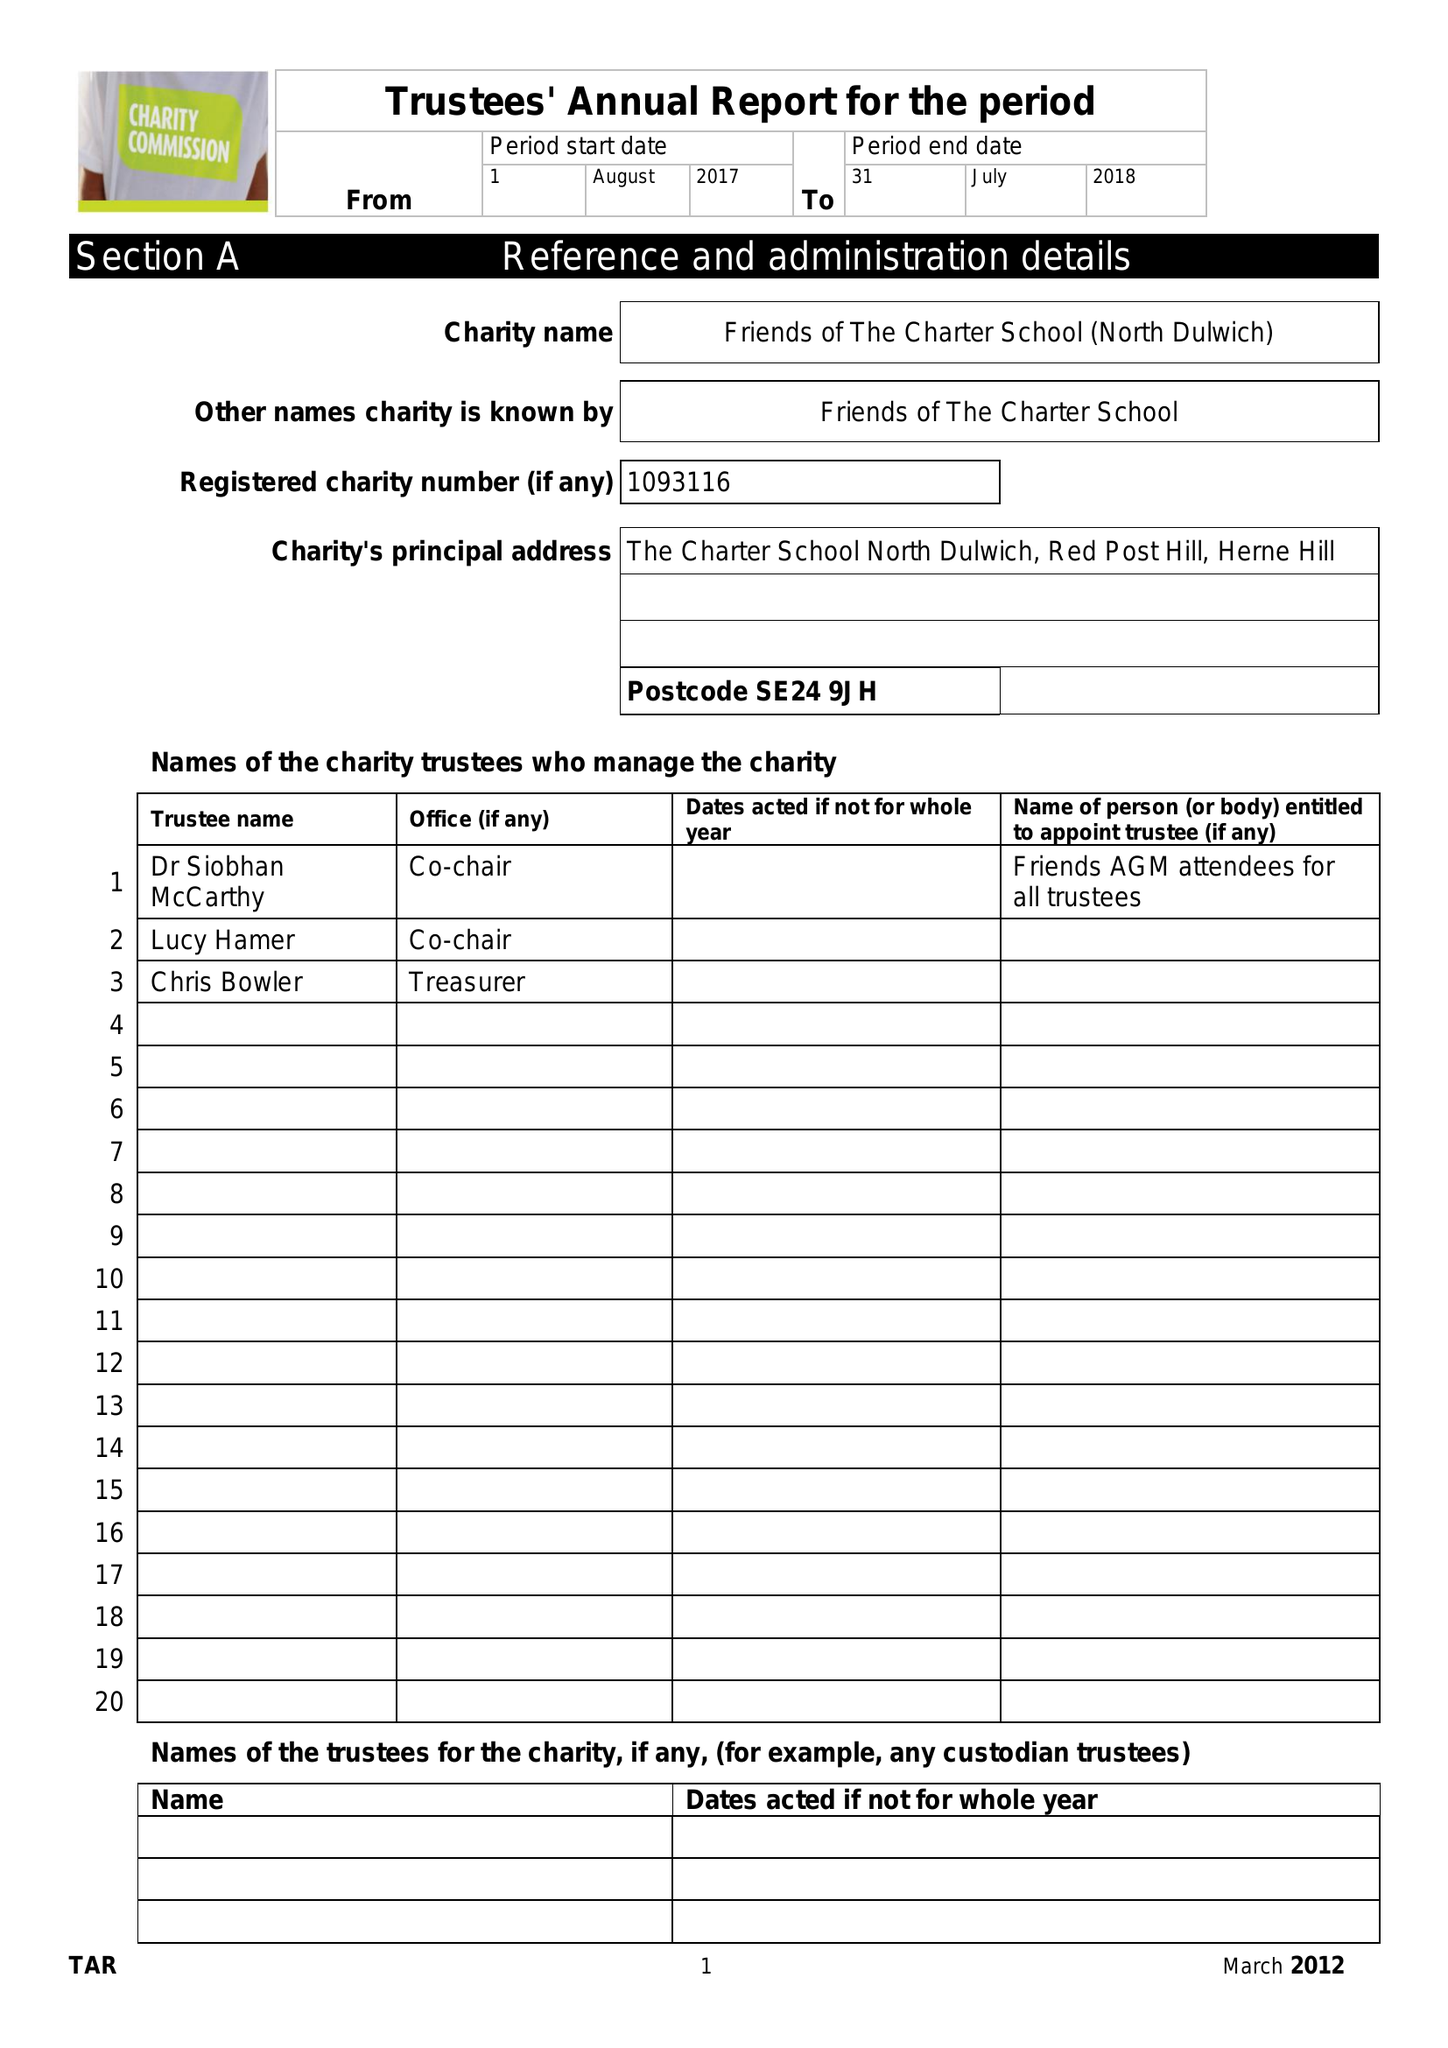What is the value for the charity_name?
Answer the question using a single word or phrase. Friends Of The Charter School North Dulwich 